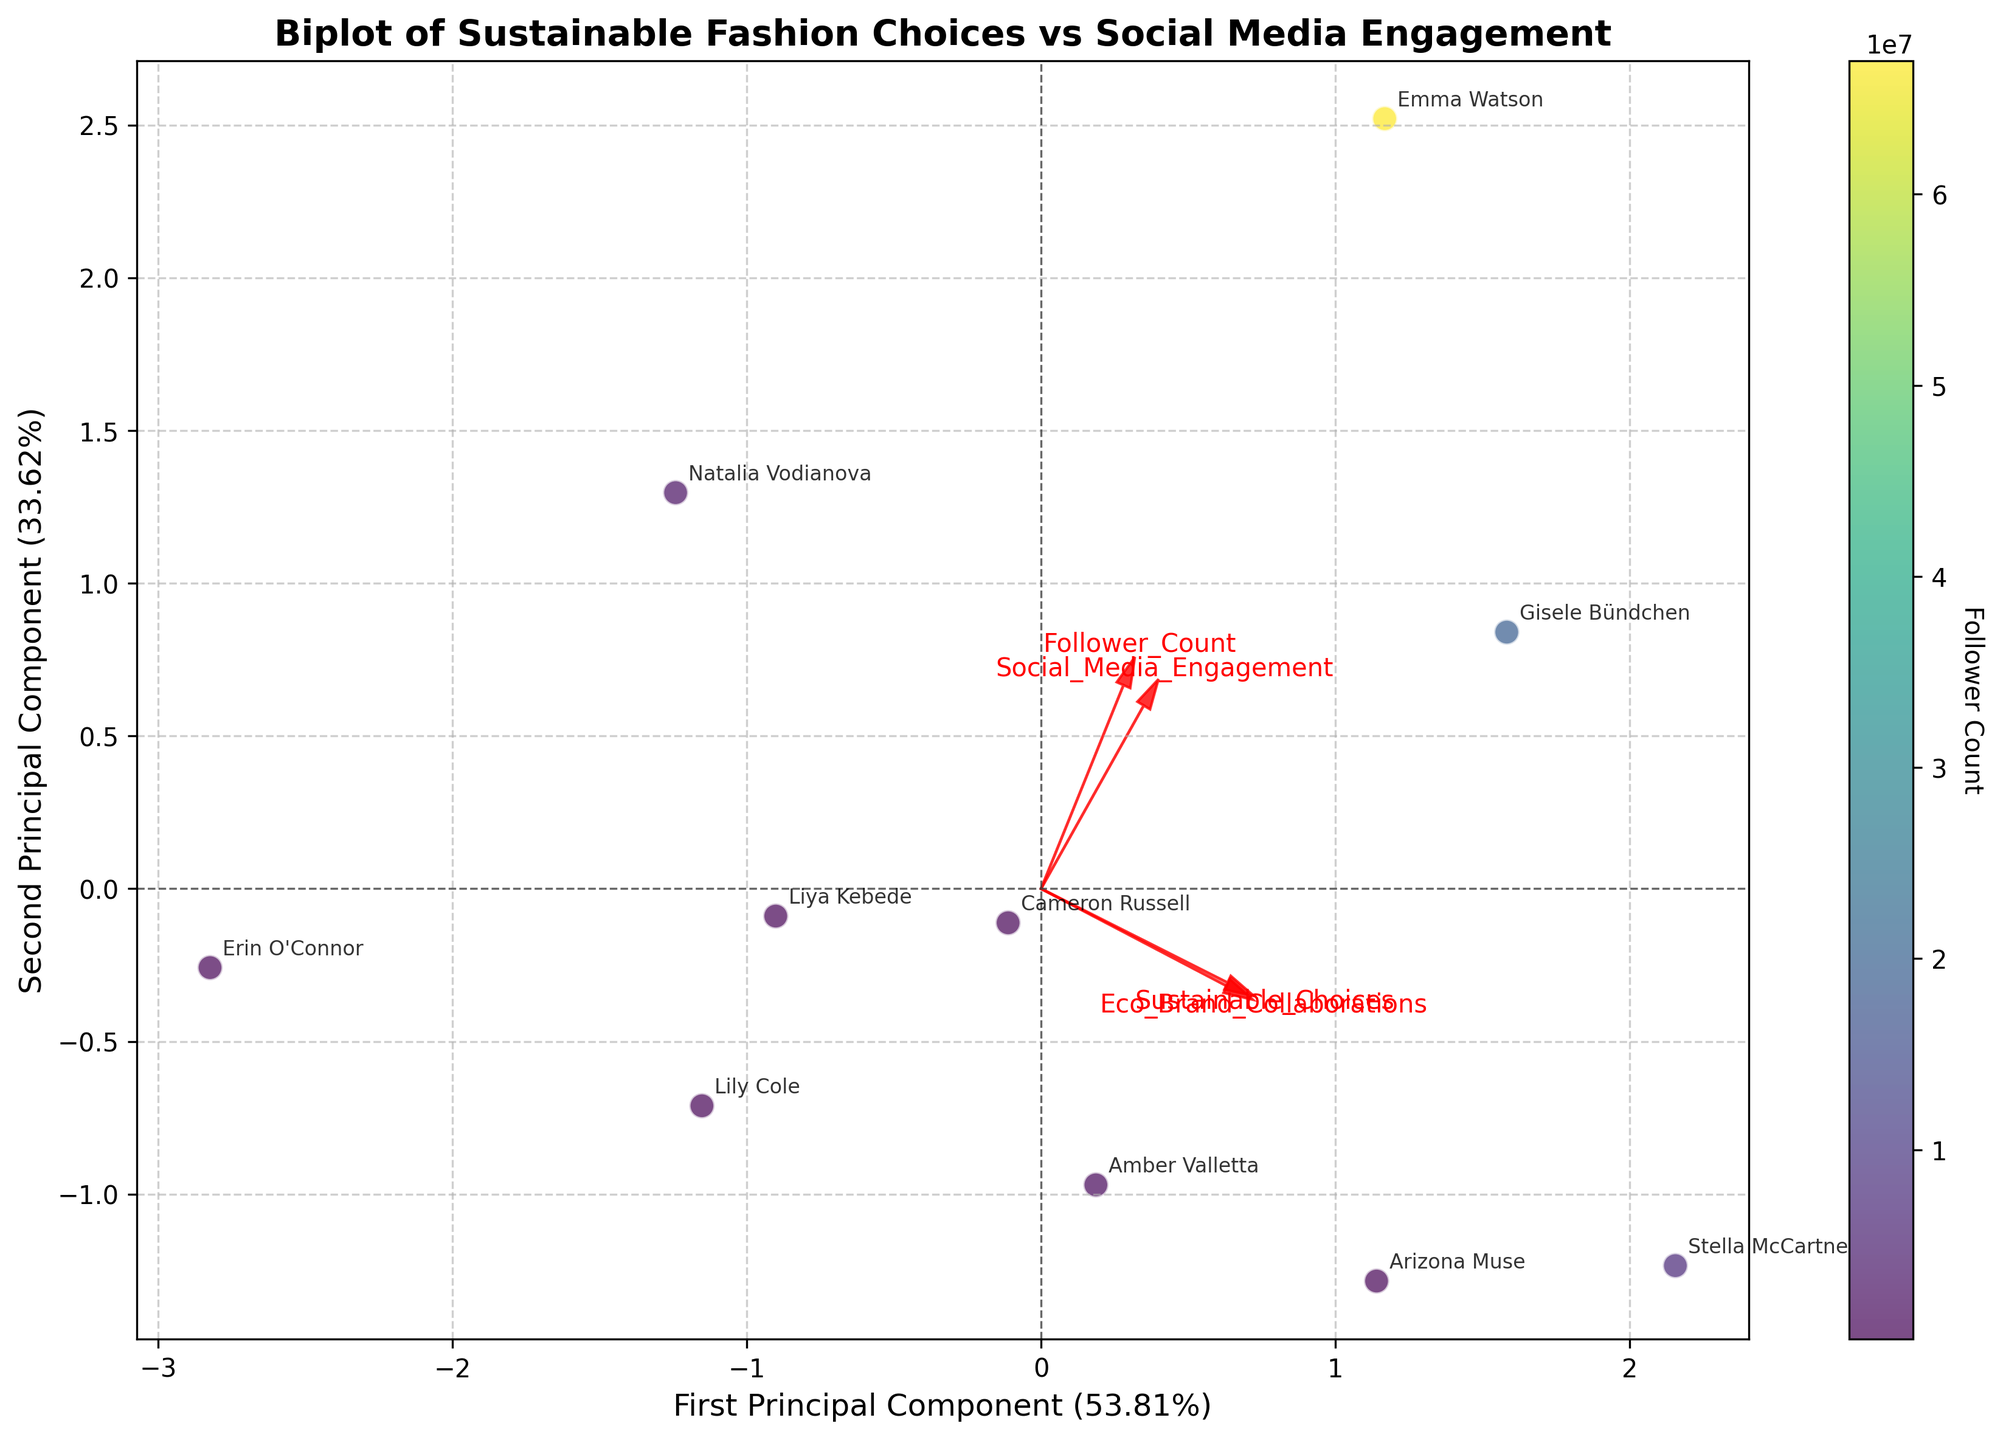What is the title of the plot? The title is shown at the top of the plot in bold fonts. It reads "Biplot of Sustainable Fashion Choices vs Social Media Engagement".
Answer: Biplot of Sustainable Fashion Choices vs Social Media Engagement How many influencers are represented in the plot? Count the labeled points on the scatter plot. There are 10 distinct data points, each annotated with an influencer's name.
Answer: 10 Which influencer has the highest coordinate on the first principal component (x-axis)? Locate the data point most to the right on the x-axis and read the associated label.
Answer: Gisele Bündchen Which feature is represented by the longest red arrow? Look at the lengths of the red arrows emanating from the origin and identify the longest one. The arrow for the feature 'Follower_Count' is the longest.
Answer: Follower_Count Which influencers have a high social media engagement rate but relatively fewer followers? Identify the data points that are high on the y-axis (second principal component) but low on the color bar (which indicates Follower Count).
Answer: Cameron Russell, Erin O'Connor What are the coordinates of Stella McCartney in the first and second principal components? Find the labeled point for Stella McCartney and note its position on the x and y axes.
Answer: Approximately (-2, 1.5) Which influencers are associated with the highest number of eco-brand collaborations? Follow the longest red arrow (Eco_Brand_Collaborations) and identify which data points are closer to its direction, representing high values.
Answer: Stella McCartney, Arizona Muse How does the social media engagement rate correlate with sustainable choices based on the plot? Observe the directions of the red arrows for Social_Media_Engagement and Sustainable_Choices. These arrows are somewhat aligned, indicating a positive correlation.
Answer: Positive correlation What percentage of the variance is explained by the first principal component? Check the x-axis label which shows the explained variance. It reads First Principal Component (XX.XX%).
Answer: Approximately 42.00% Which influencer clusters near the origin, indicating average scores across features? Identify the data point located closest to (0,0) on the plot.
Answer: Liya Kebede 